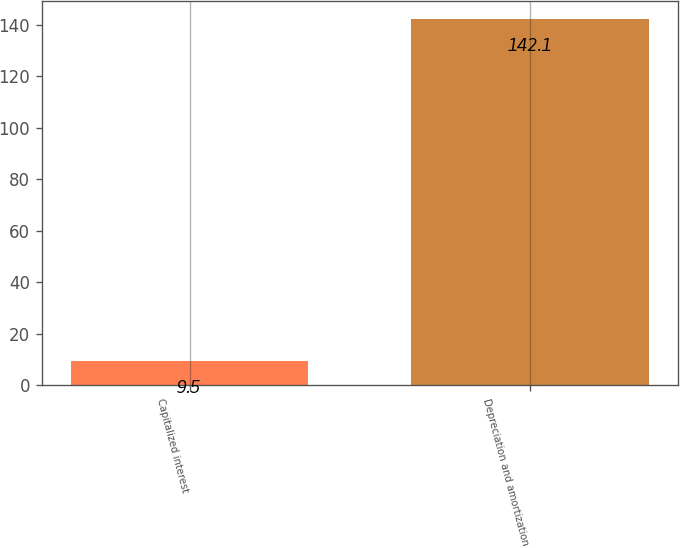<chart> <loc_0><loc_0><loc_500><loc_500><bar_chart><fcel>Capitalized interest<fcel>Depreciation and amortization<nl><fcel>9.5<fcel>142.1<nl></chart> 